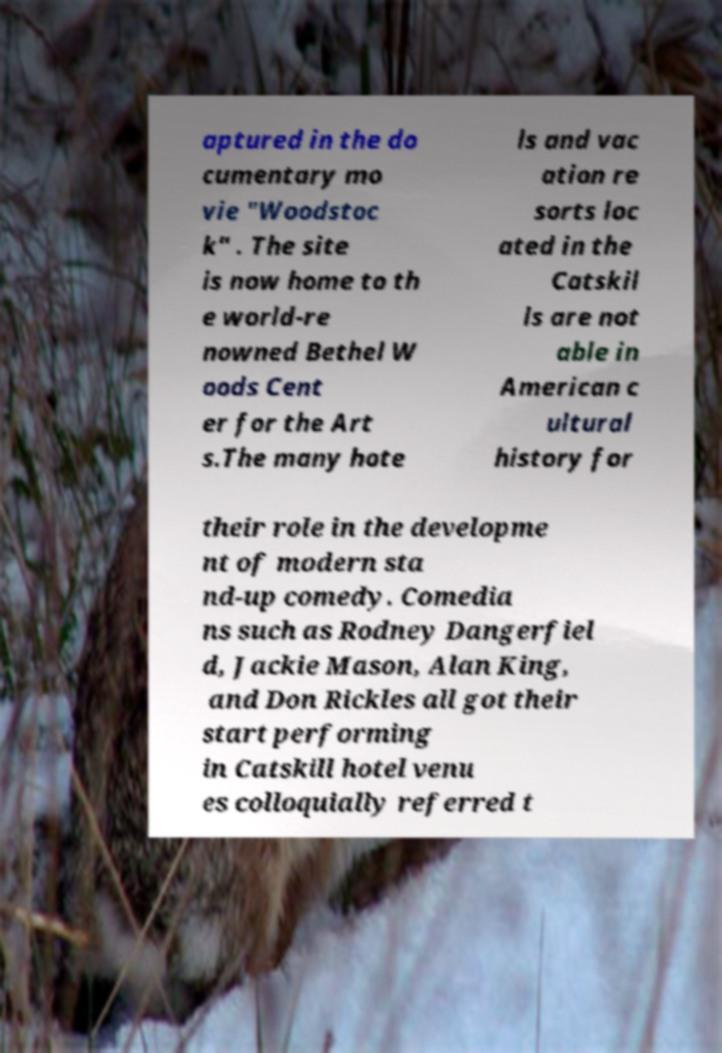There's text embedded in this image that I need extracted. Can you transcribe it verbatim? aptured in the do cumentary mo vie "Woodstoc k" . The site is now home to th e world-re nowned Bethel W oods Cent er for the Art s.The many hote ls and vac ation re sorts loc ated in the Catskil ls are not able in American c ultural history for their role in the developme nt of modern sta nd-up comedy. Comedia ns such as Rodney Dangerfiel d, Jackie Mason, Alan King, and Don Rickles all got their start performing in Catskill hotel venu es colloquially referred t 